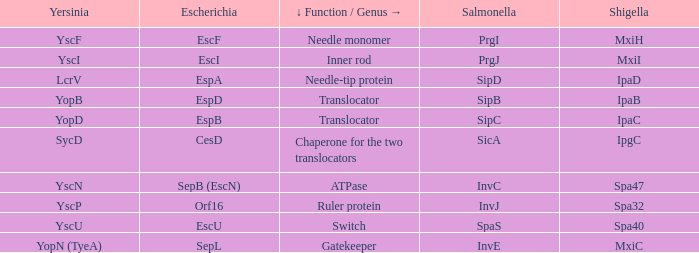Inform me about the shigella and yscn. Spa47. 